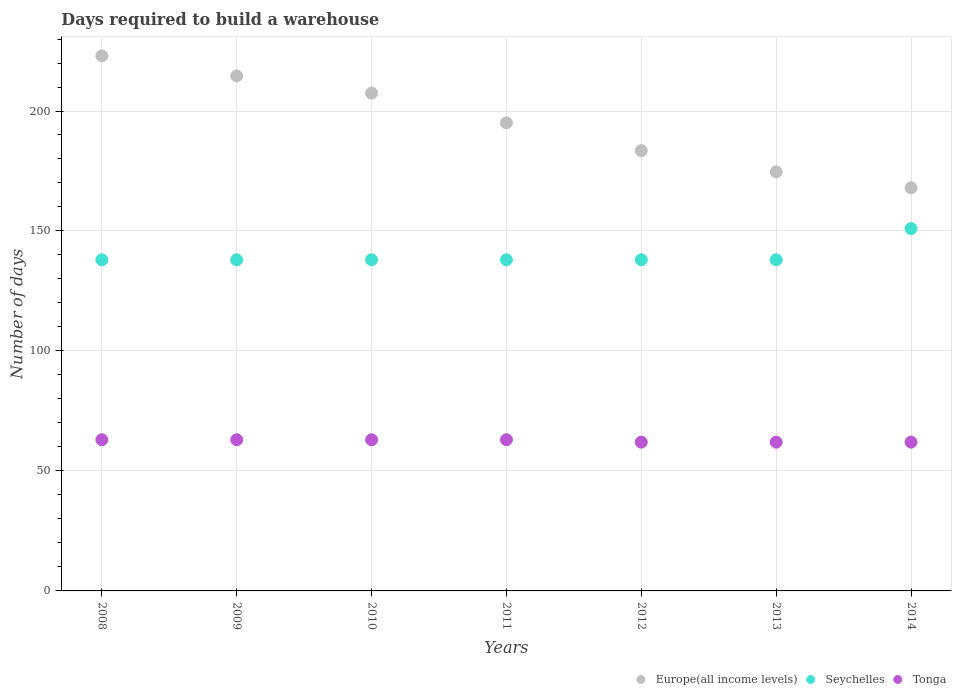What is the days required to build a warehouse in in Tonga in 2014?
Give a very brief answer. 62. Across all years, what is the maximum days required to build a warehouse in in Tonga?
Ensure brevity in your answer.  63. Across all years, what is the minimum days required to build a warehouse in in Tonga?
Give a very brief answer. 62. In which year was the days required to build a warehouse in in Europe(all income levels) minimum?
Give a very brief answer. 2014. What is the total days required to build a warehouse in in Tonga in the graph?
Make the answer very short. 438. What is the difference between the days required to build a warehouse in in Europe(all income levels) in 2008 and that in 2011?
Your answer should be compact. 27.89. What is the difference between the days required to build a warehouse in in Europe(all income levels) in 2012 and the days required to build a warehouse in in Tonga in 2009?
Provide a short and direct response. 120.47. What is the average days required to build a warehouse in in Tonga per year?
Offer a terse response. 62.57. In the year 2013, what is the difference between the days required to build a warehouse in in Seychelles and days required to build a warehouse in in Tonga?
Make the answer very short. 76. What is the ratio of the days required to build a warehouse in in Europe(all income levels) in 2012 to that in 2013?
Give a very brief answer. 1.05. Is the days required to build a warehouse in in Seychelles in 2009 less than that in 2010?
Keep it short and to the point. No. Is the difference between the days required to build a warehouse in in Seychelles in 2010 and 2013 greater than the difference between the days required to build a warehouse in in Tonga in 2010 and 2013?
Provide a short and direct response. No. What is the difference between the highest and the lowest days required to build a warehouse in in Europe(all income levels)?
Provide a succinct answer. 54.97. In how many years, is the days required to build a warehouse in in Europe(all income levels) greater than the average days required to build a warehouse in in Europe(all income levels) taken over all years?
Make the answer very short. 3. Is the sum of the days required to build a warehouse in in Europe(all income levels) in 2008 and 2011 greater than the maximum days required to build a warehouse in in Seychelles across all years?
Your answer should be compact. Yes. Is it the case that in every year, the sum of the days required to build a warehouse in in Europe(all income levels) and days required to build a warehouse in in Seychelles  is greater than the days required to build a warehouse in in Tonga?
Ensure brevity in your answer.  Yes. How many dotlines are there?
Provide a short and direct response. 3. How many years are there in the graph?
Ensure brevity in your answer.  7. Does the graph contain any zero values?
Give a very brief answer. No. Does the graph contain grids?
Ensure brevity in your answer.  Yes. How many legend labels are there?
Your response must be concise. 3. What is the title of the graph?
Your answer should be compact. Days required to build a warehouse. Does "Sint Maarten (Dutch part)" appear as one of the legend labels in the graph?
Your response must be concise. No. What is the label or title of the Y-axis?
Provide a short and direct response. Number of days. What is the Number of days of Europe(all income levels) in 2008?
Your answer should be compact. 222.97. What is the Number of days in Seychelles in 2008?
Provide a succinct answer. 138. What is the Number of days of Europe(all income levels) in 2009?
Give a very brief answer. 214.63. What is the Number of days in Seychelles in 2009?
Ensure brevity in your answer.  138. What is the Number of days of Europe(all income levels) in 2010?
Ensure brevity in your answer.  207.45. What is the Number of days of Seychelles in 2010?
Give a very brief answer. 138. What is the Number of days in Europe(all income levels) in 2011?
Your response must be concise. 195.08. What is the Number of days in Seychelles in 2011?
Your answer should be very brief. 138. What is the Number of days of Tonga in 2011?
Your response must be concise. 63. What is the Number of days in Europe(all income levels) in 2012?
Provide a succinct answer. 183.47. What is the Number of days of Seychelles in 2012?
Ensure brevity in your answer.  138. What is the Number of days of Europe(all income levels) in 2013?
Ensure brevity in your answer.  174.64. What is the Number of days in Seychelles in 2013?
Your response must be concise. 138. What is the Number of days of Tonga in 2013?
Provide a short and direct response. 62. What is the Number of days in Europe(all income levels) in 2014?
Offer a very short reply. 168. What is the Number of days of Seychelles in 2014?
Your answer should be compact. 151. What is the Number of days in Tonga in 2014?
Give a very brief answer. 62. Across all years, what is the maximum Number of days of Europe(all income levels)?
Keep it short and to the point. 222.97. Across all years, what is the maximum Number of days of Seychelles?
Offer a very short reply. 151. Across all years, what is the maximum Number of days of Tonga?
Keep it short and to the point. 63. Across all years, what is the minimum Number of days of Europe(all income levels)?
Your response must be concise. 168. Across all years, what is the minimum Number of days in Seychelles?
Provide a succinct answer. 138. What is the total Number of days of Europe(all income levels) in the graph?
Provide a succinct answer. 1366.22. What is the total Number of days in Seychelles in the graph?
Ensure brevity in your answer.  979. What is the total Number of days of Tonga in the graph?
Your response must be concise. 438. What is the difference between the Number of days in Europe(all income levels) in 2008 and that in 2009?
Your answer should be very brief. 8.34. What is the difference between the Number of days of Seychelles in 2008 and that in 2009?
Ensure brevity in your answer.  0. What is the difference between the Number of days in Tonga in 2008 and that in 2009?
Make the answer very short. 0. What is the difference between the Number of days of Europe(all income levels) in 2008 and that in 2010?
Your answer should be compact. 15.52. What is the difference between the Number of days in Seychelles in 2008 and that in 2010?
Give a very brief answer. 0. What is the difference between the Number of days in Europe(all income levels) in 2008 and that in 2011?
Keep it short and to the point. 27.89. What is the difference between the Number of days of Europe(all income levels) in 2008 and that in 2012?
Offer a terse response. 39.5. What is the difference between the Number of days in Seychelles in 2008 and that in 2012?
Offer a very short reply. 0. What is the difference between the Number of days of Tonga in 2008 and that in 2012?
Offer a very short reply. 1. What is the difference between the Number of days in Europe(all income levels) in 2008 and that in 2013?
Provide a short and direct response. 48.33. What is the difference between the Number of days of Tonga in 2008 and that in 2013?
Provide a short and direct response. 1. What is the difference between the Number of days in Europe(all income levels) in 2008 and that in 2014?
Provide a short and direct response. 54.97. What is the difference between the Number of days in Tonga in 2008 and that in 2014?
Your answer should be compact. 1. What is the difference between the Number of days of Europe(all income levels) in 2009 and that in 2010?
Ensure brevity in your answer.  7.18. What is the difference between the Number of days of Europe(all income levels) in 2009 and that in 2011?
Ensure brevity in your answer.  19.55. What is the difference between the Number of days in Seychelles in 2009 and that in 2011?
Your answer should be compact. 0. What is the difference between the Number of days of Europe(all income levels) in 2009 and that in 2012?
Provide a succinct answer. 31.16. What is the difference between the Number of days of Europe(all income levels) in 2009 and that in 2013?
Give a very brief answer. 39.99. What is the difference between the Number of days in Europe(all income levels) in 2009 and that in 2014?
Ensure brevity in your answer.  46.63. What is the difference between the Number of days in Seychelles in 2009 and that in 2014?
Make the answer very short. -13. What is the difference between the Number of days in Tonga in 2009 and that in 2014?
Give a very brief answer. 1. What is the difference between the Number of days of Europe(all income levels) in 2010 and that in 2011?
Offer a terse response. 12.37. What is the difference between the Number of days of Tonga in 2010 and that in 2011?
Offer a terse response. 0. What is the difference between the Number of days of Europe(all income levels) in 2010 and that in 2012?
Provide a succinct answer. 23.98. What is the difference between the Number of days in Seychelles in 2010 and that in 2012?
Your answer should be very brief. 0. What is the difference between the Number of days of Tonga in 2010 and that in 2012?
Keep it short and to the point. 1. What is the difference between the Number of days in Europe(all income levels) in 2010 and that in 2013?
Your answer should be compact. 32.81. What is the difference between the Number of days in Europe(all income levels) in 2010 and that in 2014?
Offer a terse response. 39.45. What is the difference between the Number of days of Seychelles in 2010 and that in 2014?
Give a very brief answer. -13. What is the difference between the Number of days of Europe(all income levels) in 2011 and that in 2012?
Your answer should be compact. 11.61. What is the difference between the Number of days in Seychelles in 2011 and that in 2012?
Provide a short and direct response. 0. What is the difference between the Number of days in Europe(all income levels) in 2011 and that in 2013?
Your answer should be very brief. 20.44. What is the difference between the Number of days in Seychelles in 2011 and that in 2013?
Provide a short and direct response. 0. What is the difference between the Number of days of Tonga in 2011 and that in 2013?
Provide a short and direct response. 1. What is the difference between the Number of days of Europe(all income levels) in 2011 and that in 2014?
Your response must be concise. 27.08. What is the difference between the Number of days in Tonga in 2011 and that in 2014?
Keep it short and to the point. 1. What is the difference between the Number of days of Europe(all income levels) in 2012 and that in 2013?
Your answer should be compact. 8.83. What is the difference between the Number of days of Tonga in 2012 and that in 2013?
Provide a succinct answer. 0. What is the difference between the Number of days of Europe(all income levels) in 2012 and that in 2014?
Give a very brief answer. 15.47. What is the difference between the Number of days in Seychelles in 2012 and that in 2014?
Ensure brevity in your answer.  -13. What is the difference between the Number of days of Tonga in 2012 and that in 2014?
Your answer should be compact. 0. What is the difference between the Number of days of Europe(all income levels) in 2013 and that in 2014?
Your answer should be compact. 6.64. What is the difference between the Number of days in Seychelles in 2013 and that in 2014?
Provide a short and direct response. -13. What is the difference between the Number of days of Tonga in 2013 and that in 2014?
Provide a succinct answer. 0. What is the difference between the Number of days in Europe(all income levels) in 2008 and the Number of days in Seychelles in 2009?
Offer a terse response. 84.97. What is the difference between the Number of days of Europe(all income levels) in 2008 and the Number of days of Tonga in 2009?
Offer a terse response. 159.97. What is the difference between the Number of days of Seychelles in 2008 and the Number of days of Tonga in 2009?
Keep it short and to the point. 75. What is the difference between the Number of days in Europe(all income levels) in 2008 and the Number of days in Seychelles in 2010?
Give a very brief answer. 84.97. What is the difference between the Number of days in Europe(all income levels) in 2008 and the Number of days in Tonga in 2010?
Make the answer very short. 159.97. What is the difference between the Number of days in Seychelles in 2008 and the Number of days in Tonga in 2010?
Keep it short and to the point. 75. What is the difference between the Number of days of Europe(all income levels) in 2008 and the Number of days of Seychelles in 2011?
Your answer should be compact. 84.97. What is the difference between the Number of days of Europe(all income levels) in 2008 and the Number of days of Tonga in 2011?
Offer a very short reply. 159.97. What is the difference between the Number of days in Europe(all income levels) in 2008 and the Number of days in Seychelles in 2012?
Offer a terse response. 84.97. What is the difference between the Number of days in Europe(all income levels) in 2008 and the Number of days in Tonga in 2012?
Provide a short and direct response. 160.97. What is the difference between the Number of days in Seychelles in 2008 and the Number of days in Tonga in 2012?
Your response must be concise. 76. What is the difference between the Number of days of Europe(all income levels) in 2008 and the Number of days of Seychelles in 2013?
Ensure brevity in your answer.  84.97. What is the difference between the Number of days of Europe(all income levels) in 2008 and the Number of days of Tonga in 2013?
Ensure brevity in your answer.  160.97. What is the difference between the Number of days in Europe(all income levels) in 2008 and the Number of days in Seychelles in 2014?
Give a very brief answer. 71.97. What is the difference between the Number of days of Europe(all income levels) in 2008 and the Number of days of Tonga in 2014?
Your response must be concise. 160.97. What is the difference between the Number of days of Europe(all income levels) in 2009 and the Number of days of Seychelles in 2010?
Make the answer very short. 76.63. What is the difference between the Number of days in Europe(all income levels) in 2009 and the Number of days in Tonga in 2010?
Provide a succinct answer. 151.63. What is the difference between the Number of days of Europe(all income levels) in 2009 and the Number of days of Seychelles in 2011?
Your response must be concise. 76.63. What is the difference between the Number of days in Europe(all income levels) in 2009 and the Number of days in Tonga in 2011?
Keep it short and to the point. 151.63. What is the difference between the Number of days of Seychelles in 2009 and the Number of days of Tonga in 2011?
Make the answer very short. 75. What is the difference between the Number of days of Europe(all income levels) in 2009 and the Number of days of Seychelles in 2012?
Your response must be concise. 76.63. What is the difference between the Number of days in Europe(all income levels) in 2009 and the Number of days in Tonga in 2012?
Provide a succinct answer. 152.63. What is the difference between the Number of days of Seychelles in 2009 and the Number of days of Tonga in 2012?
Offer a terse response. 76. What is the difference between the Number of days in Europe(all income levels) in 2009 and the Number of days in Seychelles in 2013?
Ensure brevity in your answer.  76.63. What is the difference between the Number of days of Europe(all income levels) in 2009 and the Number of days of Tonga in 2013?
Your answer should be very brief. 152.63. What is the difference between the Number of days in Seychelles in 2009 and the Number of days in Tonga in 2013?
Make the answer very short. 76. What is the difference between the Number of days of Europe(all income levels) in 2009 and the Number of days of Seychelles in 2014?
Make the answer very short. 63.63. What is the difference between the Number of days of Europe(all income levels) in 2009 and the Number of days of Tonga in 2014?
Ensure brevity in your answer.  152.63. What is the difference between the Number of days of Seychelles in 2009 and the Number of days of Tonga in 2014?
Your answer should be very brief. 76. What is the difference between the Number of days in Europe(all income levels) in 2010 and the Number of days in Seychelles in 2011?
Give a very brief answer. 69.45. What is the difference between the Number of days of Europe(all income levels) in 2010 and the Number of days of Tonga in 2011?
Make the answer very short. 144.45. What is the difference between the Number of days of Europe(all income levels) in 2010 and the Number of days of Seychelles in 2012?
Your response must be concise. 69.45. What is the difference between the Number of days in Europe(all income levels) in 2010 and the Number of days in Tonga in 2012?
Your answer should be very brief. 145.45. What is the difference between the Number of days of Seychelles in 2010 and the Number of days of Tonga in 2012?
Your answer should be compact. 76. What is the difference between the Number of days in Europe(all income levels) in 2010 and the Number of days in Seychelles in 2013?
Give a very brief answer. 69.45. What is the difference between the Number of days of Europe(all income levels) in 2010 and the Number of days of Tonga in 2013?
Ensure brevity in your answer.  145.45. What is the difference between the Number of days in Seychelles in 2010 and the Number of days in Tonga in 2013?
Make the answer very short. 76. What is the difference between the Number of days in Europe(all income levels) in 2010 and the Number of days in Seychelles in 2014?
Keep it short and to the point. 56.45. What is the difference between the Number of days in Europe(all income levels) in 2010 and the Number of days in Tonga in 2014?
Make the answer very short. 145.45. What is the difference between the Number of days in Europe(all income levels) in 2011 and the Number of days in Seychelles in 2012?
Your answer should be very brief. 57.08. What is the difference between the Number of days in Europe(all income levels) in 2011 and the Number of days in Tonga in 2012?
Give a very brief answer. 133.08. What is the difference between the Number of days in Europe(all income levels) in 2011 and the Number of days in Seychelles in 2013?
Provide a short and direct response. 57.08. What is the difference between the Number of days in Europe(all income levels) in 2011 and the Number of days in Tonga in 2013?
Your response must be concise. 133.08. What is the difference between the Number of days in Europe(all income levels) in 2011 and the Number of days in Seychelles in 2014?
Make the answer very short. 44.08. What is the difference between the Number of days in Europe(all income levels) in 2011 and the Number of days in Tonga in 2014?
Make the answer very short. 133.08. What is the difference between the Number of days in Europe(all income levels) in 2012 and the Number of days in Seychelles in 2013?
Provide a short and direct response. 45.47. What is the difference between the Number of days of Europe(all income levels) in 2012 and the Number of days of Tonga in 2013?
Ensure brevity in your answer.  121.47. What is the difference between the Number of days of Europe(all income levels) in 2012 and the Number of days of Seychelles in 2014?
Provide a short and direct response. 32.47. What is the difference between the Number of days of Europe(all income levels) in 2012 and the Number of days of Tonga in 2014?
Your answer should be very brief. 121.47. What is the difference between the Number of days in Europe(all income levels) in 2013 and the Number of days in Seychelles in 2014?
Your answer should be compact. 23.64. What is the difference between the Number of days in Europe(all income levels) in 2013 and the Number of days in Tonga in 2014?
Give a very brief answer. 112.64. What is the difference between the Number of days in Seychelles in 2013 and the Number of days in Tonga in 2014?
Your response must be concise. 76. What is the average Number of days in Europe(all income levels) per year?
Make the answer very short. 195.17. What is the average Number of days in Seychelles per year?
Provide a succinct answer. 139.86. What is the average Number of days in Tonga per year?
Give a very brief answer. 62.57. In the year 2008, what is the difference between the Number of days in Europe(all income levels) and Number of days in Seychelles?
Your response must be concise. 84.97. In the year 2008, what is the difference between the Number of days of Europe(all income levels) and Number of days of Tonga?
Ensure brevity in your answer.  159.97. In the year 2008, what is the difference between the Number of days in Seychelles and Number of days in Tonga?
Provide a short and direct response. 75. In the year 2009, what is the difference between the Number of days of Europe(all income levels) and Number of days of Seychelles?
Offer a terse response. 76.63. In the year 2009, what is the difference between the Number of days of Europe(all income levels) and Number of days of Tonga?
Your answer should be very brief. 151.63. In the year 2009, what is the difference between the Number of days of Seychelles and Number of days of Tonga?
Provide a succinct answer. 75. In the year 2010, what is the difference between the Number of days of Europe(all income levels) and Number of days of Seychelles?
Your answer should be compact. 69.45. In the year 2010, what is the difference between the Number of days in Europe(all income levels) and Number of days in Tonga?
Make the answer very short. 144.45. In the year 2011, what is the difference between the Number of days of Europe(all income levels) and Number of days of Seychelles?
Ensure brevity in your answer.  57.08. In the year 2011, what is the difference between the Number of days in Europe(all income levels) and Number of days in Tonga?
Keep it short and to the point. 132.08. In the year 2011, what is the difference between the Number of days in Seychelles and Number of days in Tonga?
Keep it short and to the point. 75. In the year 2012, what is the difference between the Number of days of Europe(all income levels) and Number of days of Seychelles?
Provide a short and direct response. 45.47. In the year 2012, what is the difference between the Number of days of Europe(all income levels) and Number of days of Tonga?
Keep it short and to the point. 121.47. In the year 2013, what is the difference between the Number of days of Europe(all income levels) and Number of days of Seychelles?
Your response must be concise. 36.64. In the year 2013, what is the difference between the Number of days of Europe(all income levels) and Number of days of Tonga?
Your answer should be very brief. 112.64. In the year 2014, what is the difference between the Number of days of Europe(all income levels) and Number of days of Seychelles?
Your answer should be compact. 17. In the year 2014, what is the difference between the Number of days in Europe(all income levels) and Number of days in Tonga?
Your response must be concise. 106. In the year 2014, what is the difference between the Number of days of Seychelles and Number of days of Tonga?
Your response must be concise. 89. What is the ratio of the Number of days in Europe(all income levels) in 2008 to that in 2009?
Provide a short and direct response. 1.04. What is the ratio of the Number of days in Europe(all income levels) in 2008 to that in 2010?
Provide a succinct answer. 1.07. What is the ratio of the Number of days of Europe(all income levels) in 2008 to that in 2011?
Ensure brevity in your answer.  1.14. What is the ratio of the Number of days of Seychelles in 2008 to that in 2011?
Offer a terse response. 1. What is the ratio of the Number of days of Europe(all income levels) in 2008 to that in 2012?
Your answer should be very brief. 1.22. What is the ratio of the Number of days of Tonga in 2008 to that in 2012?
Your response must be concise. 1.02. What is the ratio of the Number of days of Europe(all income levels) in 2008 to that in 2013?
Provide a succinct answer. 1.28. What is the ratio of the Number of days of Seychelles in 2008 to that in 2013?
Provide a short and direct response. 1. What is the ratio of the Number of days of Tonga in 2008 to that in 2013?
Ensure brevity in your answer.  1.02. What is the ratio of the Number of days of Europe(all income levels) in 2008 to that in 2014?
Give a very brief answer. 1.33. What is the ratio of the Number of days of Seychelles in 2008 to that in 2014?
Your answer should be compact. 0.91. What is the ratio of the Number of days of Tonga in 2008 to that in 2014?
Ensure brevity in your answer.  1.02. What is the ratio of the Number of days of Europe(all income levels) in 2009 to that in 2010?
Offer a very short reply. 1.03. What is the ratio of the Number of days in Tonga in 2009 to that in 2010?
Make the answer very short. 1. What is the ratio of the Number of days of Europe(all income levels) in 2009 to that in 2011?
Give a very brief answer. 1.1. What is the ratio of the Number of days of Seychelles in 2009 to that in 2011?
Give a very brief answer. 1. What is the ratio of the Number of days in Tonga in 2009 to that in 2011?
Ensure brevity in your answer.  1. What is the ratio of the Number of days in Europe(all income levels) in 2009 to that in 2012?
Your answer should be very brief. 1.17. What is the ratio of the Number of days in Seychelles in 2009 to that in 2012?
Make the answer very short. 1. What is the ratio of the Number of days in Tonga in 2009 to that in 2012?
Offer a terse response. 1.02. What is the ratio of the Number of days in Europe(all income levels) in 2009 to that in 2013?
Your answer should be very brief. 1.23. What is the ratio of the Number of days in Tonga in 2009 to that in 2013?
Your response must be concise. 1.02. What is the ratio of the Number of days of Europe(all income levels) in 2009 to that in 2014?
Offer a terse response. 1.28. What is the ratio of the Number of days of Seychelles in 2009 to that in 2014?
Keep it short and to the point. 0.91. What is the ratio of the Number of days in Tonga in 2009 to that in 2014?
Give a very brief answer. 1.02. What is the ratio of the Number of days of Europe(all income levels) in 2010 to that in 2011?
Provide a succinct answer. 1.06. What is the ratio of the Number of days of Seychelles in 2010 to that in 2011?
Offer a very short reply. 1. What is the ratio of the Number of days in Tonga in 2010 to that in 2011?
Offer a very short reply. 1. What is the ratio of the Number of days in Europe(all income levels) in 2010 to that in 2012?
Ensure brevity in your answer.  1.13. What is the ratio of the Number of days in Seychelles in 2010 to that in 2012?
Keep it short and to the point. 1. What is the ratio of the Number of days in Tonga in 2010 to that in 2012?
Provide a short and direct response. 1.02. What is the ratio of the Number of days of Europe(all income levels) in 2010 to that in 2013?
Make the answer very short. 1.19. What is the ratio of the Number of days in Tonga in 2010 to that in 2013?
Your answer should be compact. 1.02. What is the ratio of the Number of days in Europe(all income levels) in 2010 to that in 2014?
Give a very brief answer. 1.23. What is the ratio of the Number of days of Seychelles in 2010 to that in 2014?
Offer a terse response. 0.91. What is the ratio of the Number of days in Tonga in 2010 to that in 2014?
Your answer should be compact. 1.02. What is the ratio of the Number of days of Europe(all income levels) in 2011 to that in 2012?
Your answer should be compact. 1.06. What is the ratio of the Number of days in Tonga in 2011 to that in 2012?
Give a very brief answer. 1.02. What is the ratio of the Number of days in Europe(all income levels) in 2011 to that in 2013?
Offer a terse response. 1.12. What is the ratio of the Number of days of Seychelles in 2011 to that in 2013?
Offer a very short reply. 1. What is the ratio of the Number of days of Tonga in 2011 to that in 2013?
Give a very brief answer. 1.02. What is the ratio of the Number of days of Europe(all income levels) in 2011 to that in 2014?
Ensure brevity in your answer.  1.16. What is the ratio of the Number of days of Seychelles in 2011 to that in 2014?
Give a very brief answer. 0.91. What is the ratio of the Number of days in Tonga in 2011 to that in 2014?
Keep it short and to the point. 1.02. What is the ratio of the Number of days in Europe(all income levels) in 2012 to that in 2013?
Offer a terse response. 1.05. What is the ratio of the Number of days in Tonga in 2012 to that in 2013?
Your response must be concise. 1. What is the ratio of the Number of days in Europe(all income levels) in 2012 to that in 2014?
Your answer should be very brief. 1.09. What is the ratio of the Number of days in Seychelles in 2012 to that in 2014?
Offer a terse response. 0.91. What is the ratio of the Number of days of Europe(all income levels) in 2013 to that in 2014?
Your answer should be compact. 1.04. What is the ratio of the Number of days of Seychelles in 2013 to that in 2014?
Your response must be concise. 0.91. What is the difference between the highest and the second highest Number of days of Europe(all income levels)?
Provide a succinct answer. 8.34. What is the difference between the highest and the lowest Number of days of Europe(all income levels)?
Your answer should be very brief. 54.97. What is the difference between the highest and the lowest Number of days in Seychelles?
Keep it short and to the point. 13. 